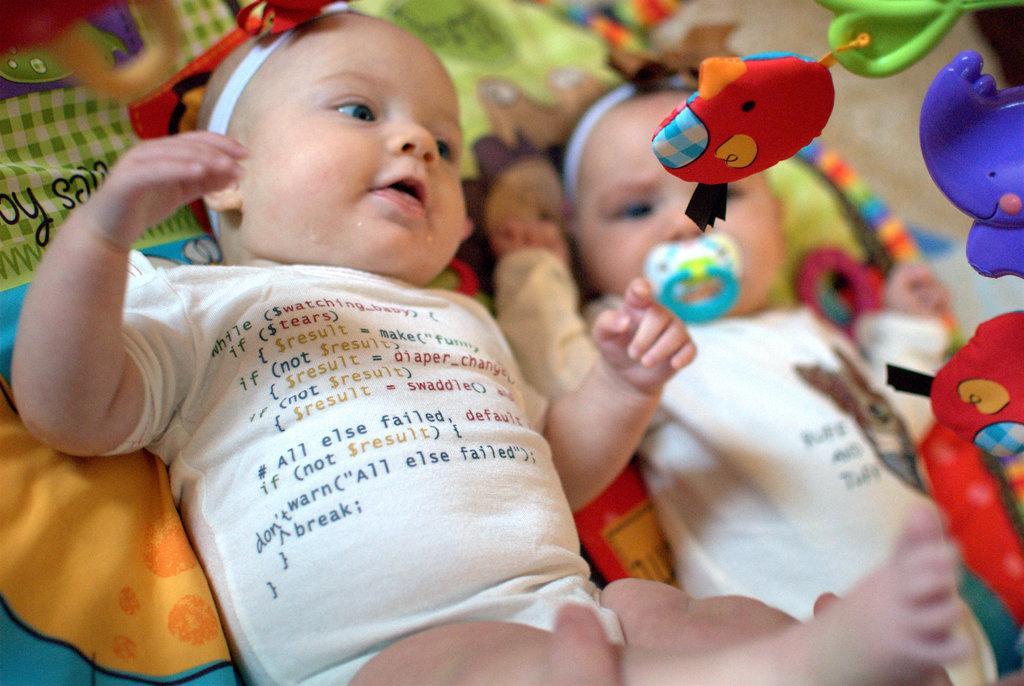Please provide a concise description of this image. In this image I can see two babies wearing white colored dresses are sleeping on the bed sheet which is orange, blue and green in color. I can see few toys which are red, blue, green and white in color. 